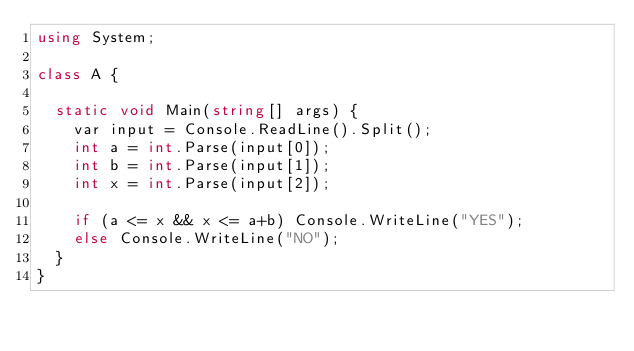<code> <loc_0><loc_0><loc_500><loc_500><_C#_>using System;

class A {
  
  static void Main(string[] args) {
    var input = Console.ReadLine().Split();
    int a = int.Parse(input[0]);
    int b = int.Parse(input[1]);
    int x = int.Parse(input[2]);
    
    if (a <= x && x <= a+b) Console.WriteLine("YES");
    else Console.WriteLine("NO");
  }
}</code> 